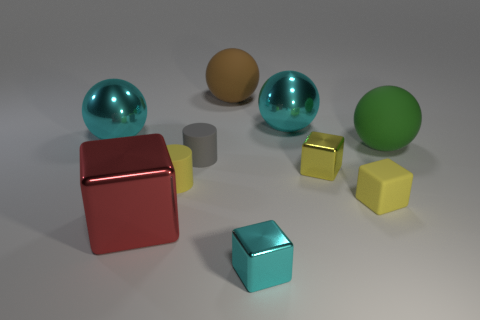Are there any yellow metal objects of the same shape as the large green thing?
Offer a very short reply. No. Does the tiny gray object have the same material as the large red cube left of the green matte thing?
Provide a succinct answer. No. What material is the large cyan sphere that is right of the cyan shiny block that is to the right of the yellow matte cylinder made of?
Provide a short and direct response. Metal. Are there more small metal things that are in front of the tiny yellow matte cylinder than large purple cylinders?
Offer a terse response. Yes. Are there any big gray metallic cylinders?
Your response must be concise. No. There is a object in front of the big block; what color is it?
Ensure brevity in your answer.  Cyan. There is a cyan cube that is the same size as the gray cylinder; what is its material?
Make the answer very short. Metal. How many other things are made of the same material as the small gray cylinder?
Provide a succinct answer. 4. There is a metallic thing that is both in front of the small matte cube and on the right side of the big block; what color is it?
Offer a terse response. Cyan. What number of things are either tiny metallic things behind the large red cube or matte cylinders?
Your response must be concise. 3. 